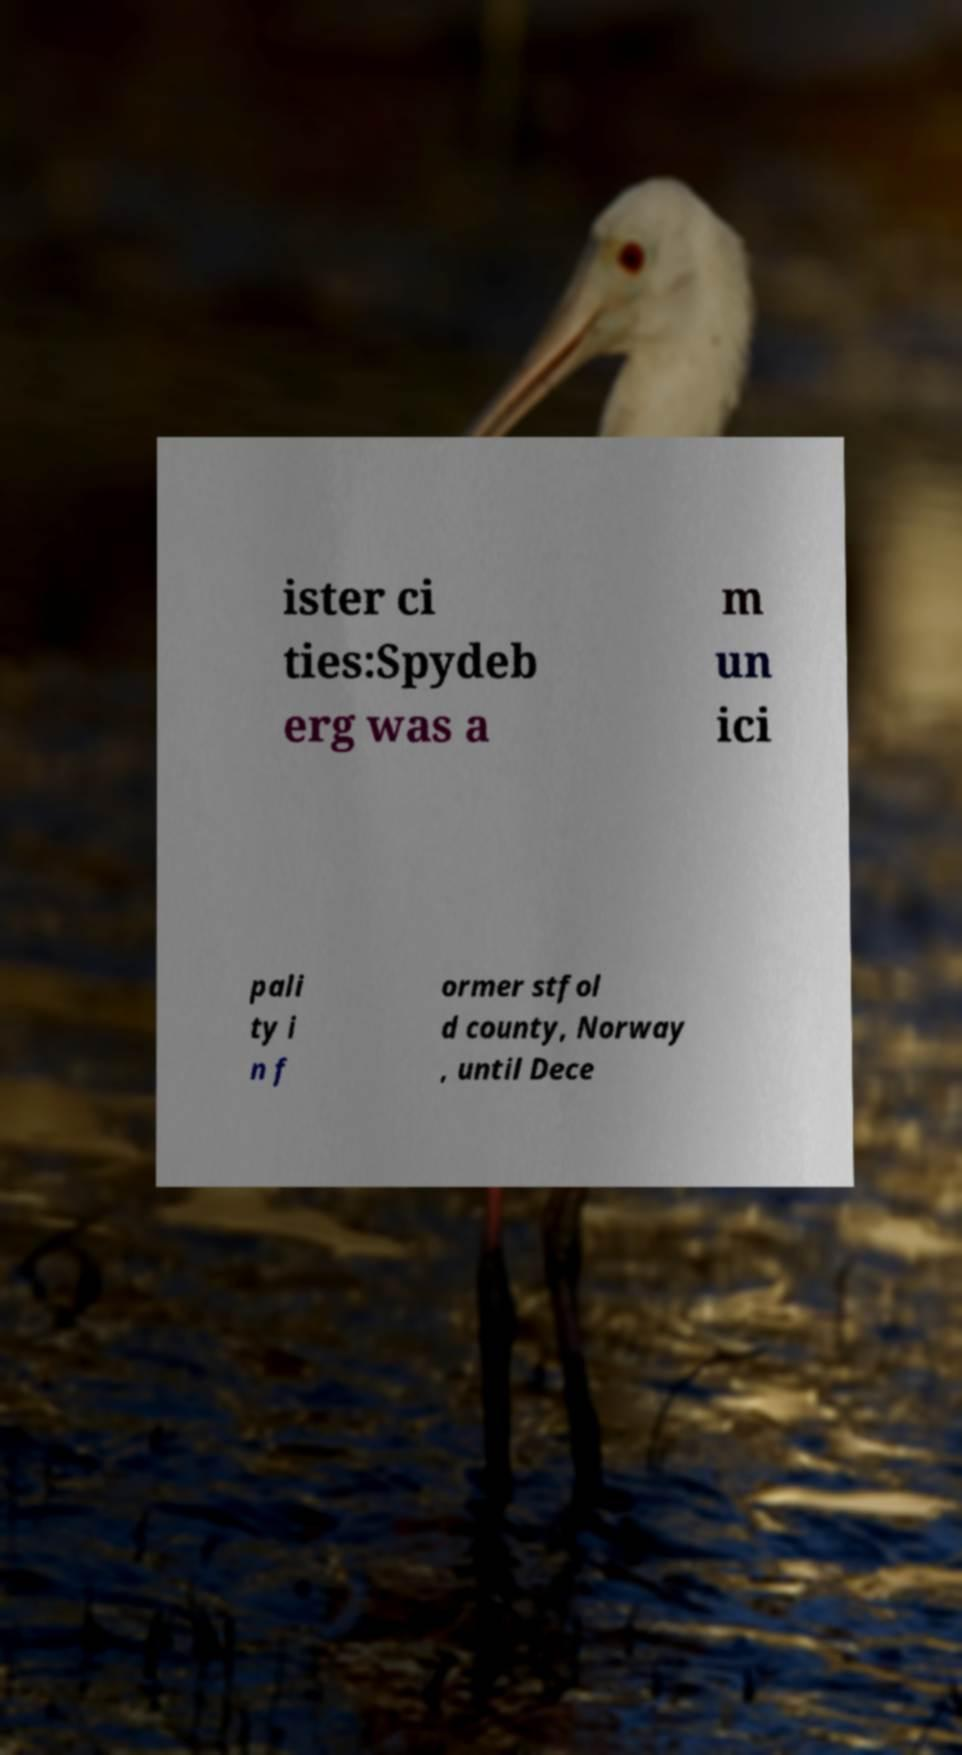I need the written content from this picture converted into text. Can you do that? ister ci ties:Spydeb erg was a m un ici pali ty i n f ormer stfol d county, Norway , until Dece 